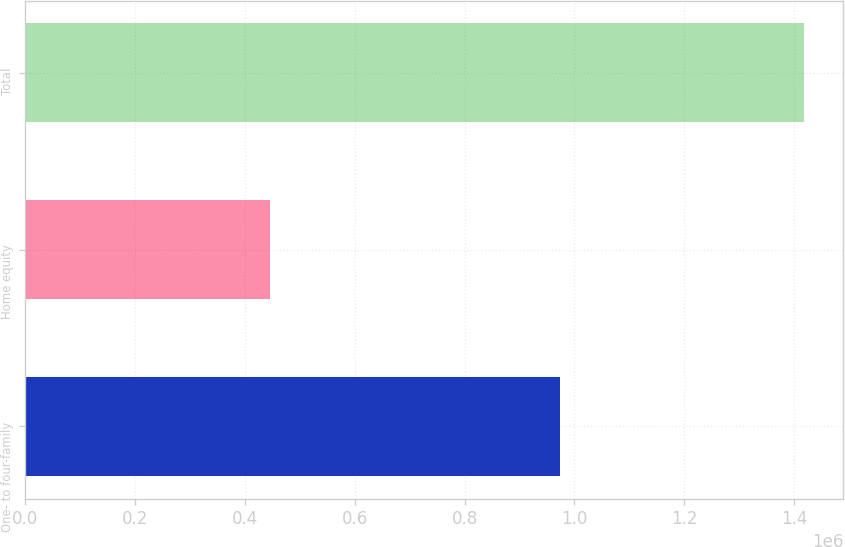<chart> <loc_0><loc_0><loc_500><loc_500><bar_chart><fcel>One- to four-family<fcel>Home equity<fcel>Total<nl><fcel>972953<fcel>445939<fcel>1.41889e+06<nl></chart> 